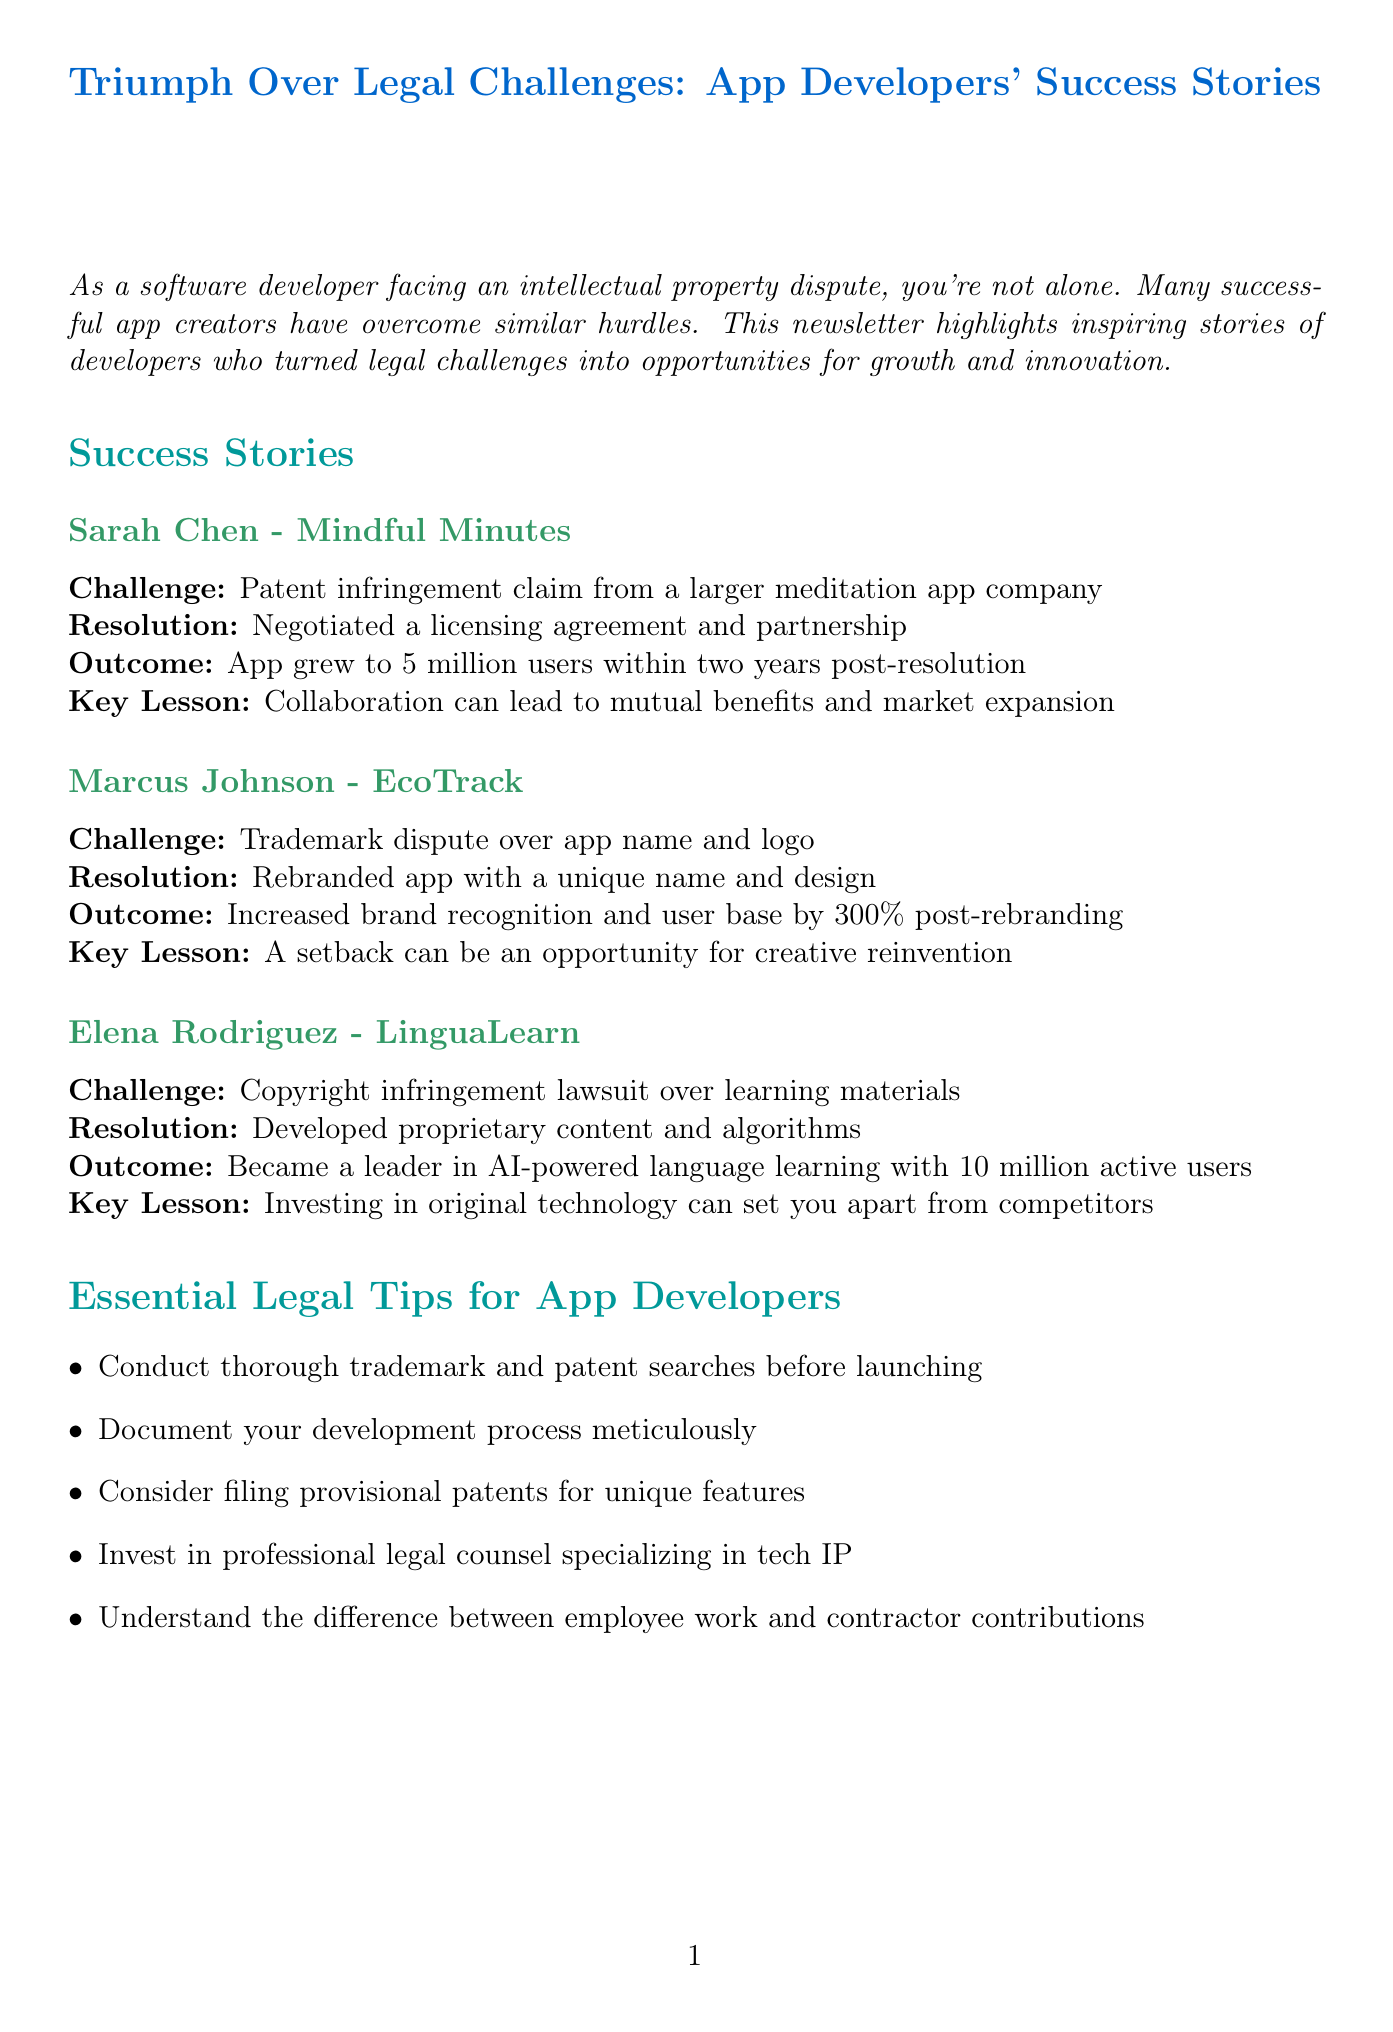what is the title of the newsletter? The title is stated at the beginning of the document.
Answer: Triumph Over Legal Challenges: App Developers' Success Stories who is the developer of Mindful Minutes? This information is presented in the success stories section.
Answer: Sarah Chen what was the legal challenge faced by Marcus Johnson? This is found in the specific story detailing Marcus Johnson's experience.
Answer: Trademark dispute over app name and logo how many users did LinguaLearn have after its resolution? This number is mentioned in the outcome of Elena Rodriguez's story.
Answer: 10 million what key lesson did Sarah Chen learn? This lesson is highlighted as a part of her success story.
Answer: Collaboration can lead to mutual benefits and market expansion what advice is given regarding trademark searches? This advice is included in the essential legal tips for app developers.
Answer: Conduct thorough trademark and patent searches before launching how much did Marcus Johnson's brand recognition increase post-rebranding? This percentage is specified in his success story outcome.
Answer: 300% what organization offers legal guidance for developers? This information is found in the resource section of the document.
Answer: App Developers Association 